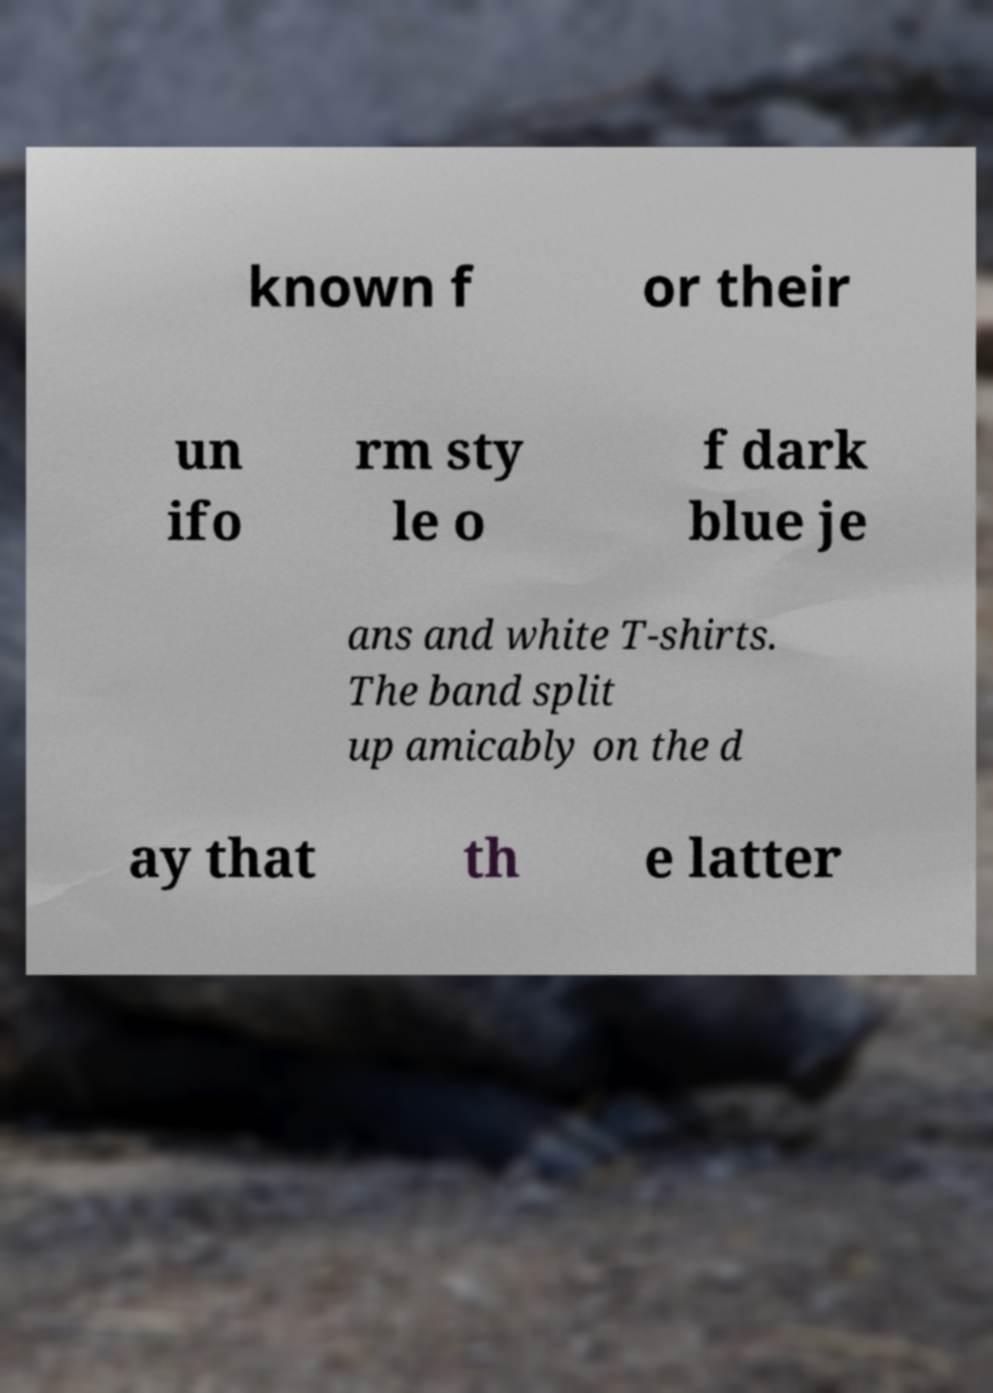Can you read and provide the text displayed in the image?This photo seems to have some interesting text. Can you extract and type it out for me? known f or their un ifo rm sty le o f dark blue je ans and white T-shirts. The band split up amicably on the d ay that th e latter 